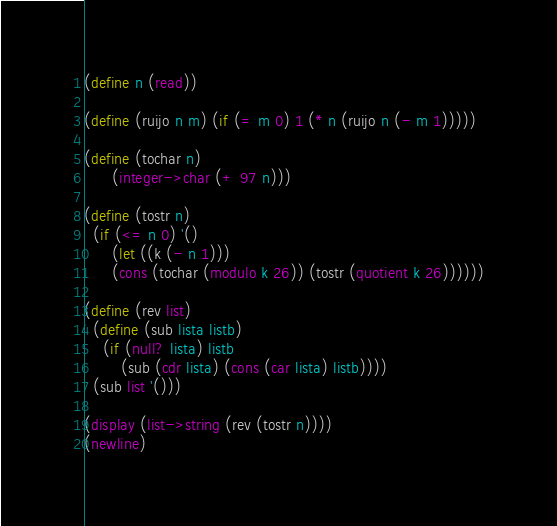Convert code to text. <code><loc_0><loc_0><loc_500><loc_500><_Scheme_>(define n (read))

(define (ruijo n m) (if (= m 0) 1 (* n (ruijo n (- m 1)))))

(define (tochar n)
      (integer->char (+ 97 n)))

(define (tostr n)
  (if (<= n 0) '()
      (let ((k (- n 1)))
      (cons (tochar (modulo k 26)) (tostr (quotient k 26))))))

(define (rev list)
  (define (sub lista listb)
    (if (null? lista) listb
        (sub (cdr lista) (cons (car lista) listb))))
  (sub list '()))

(display (list->string (rev (tostr n))))
(newline)</code> 